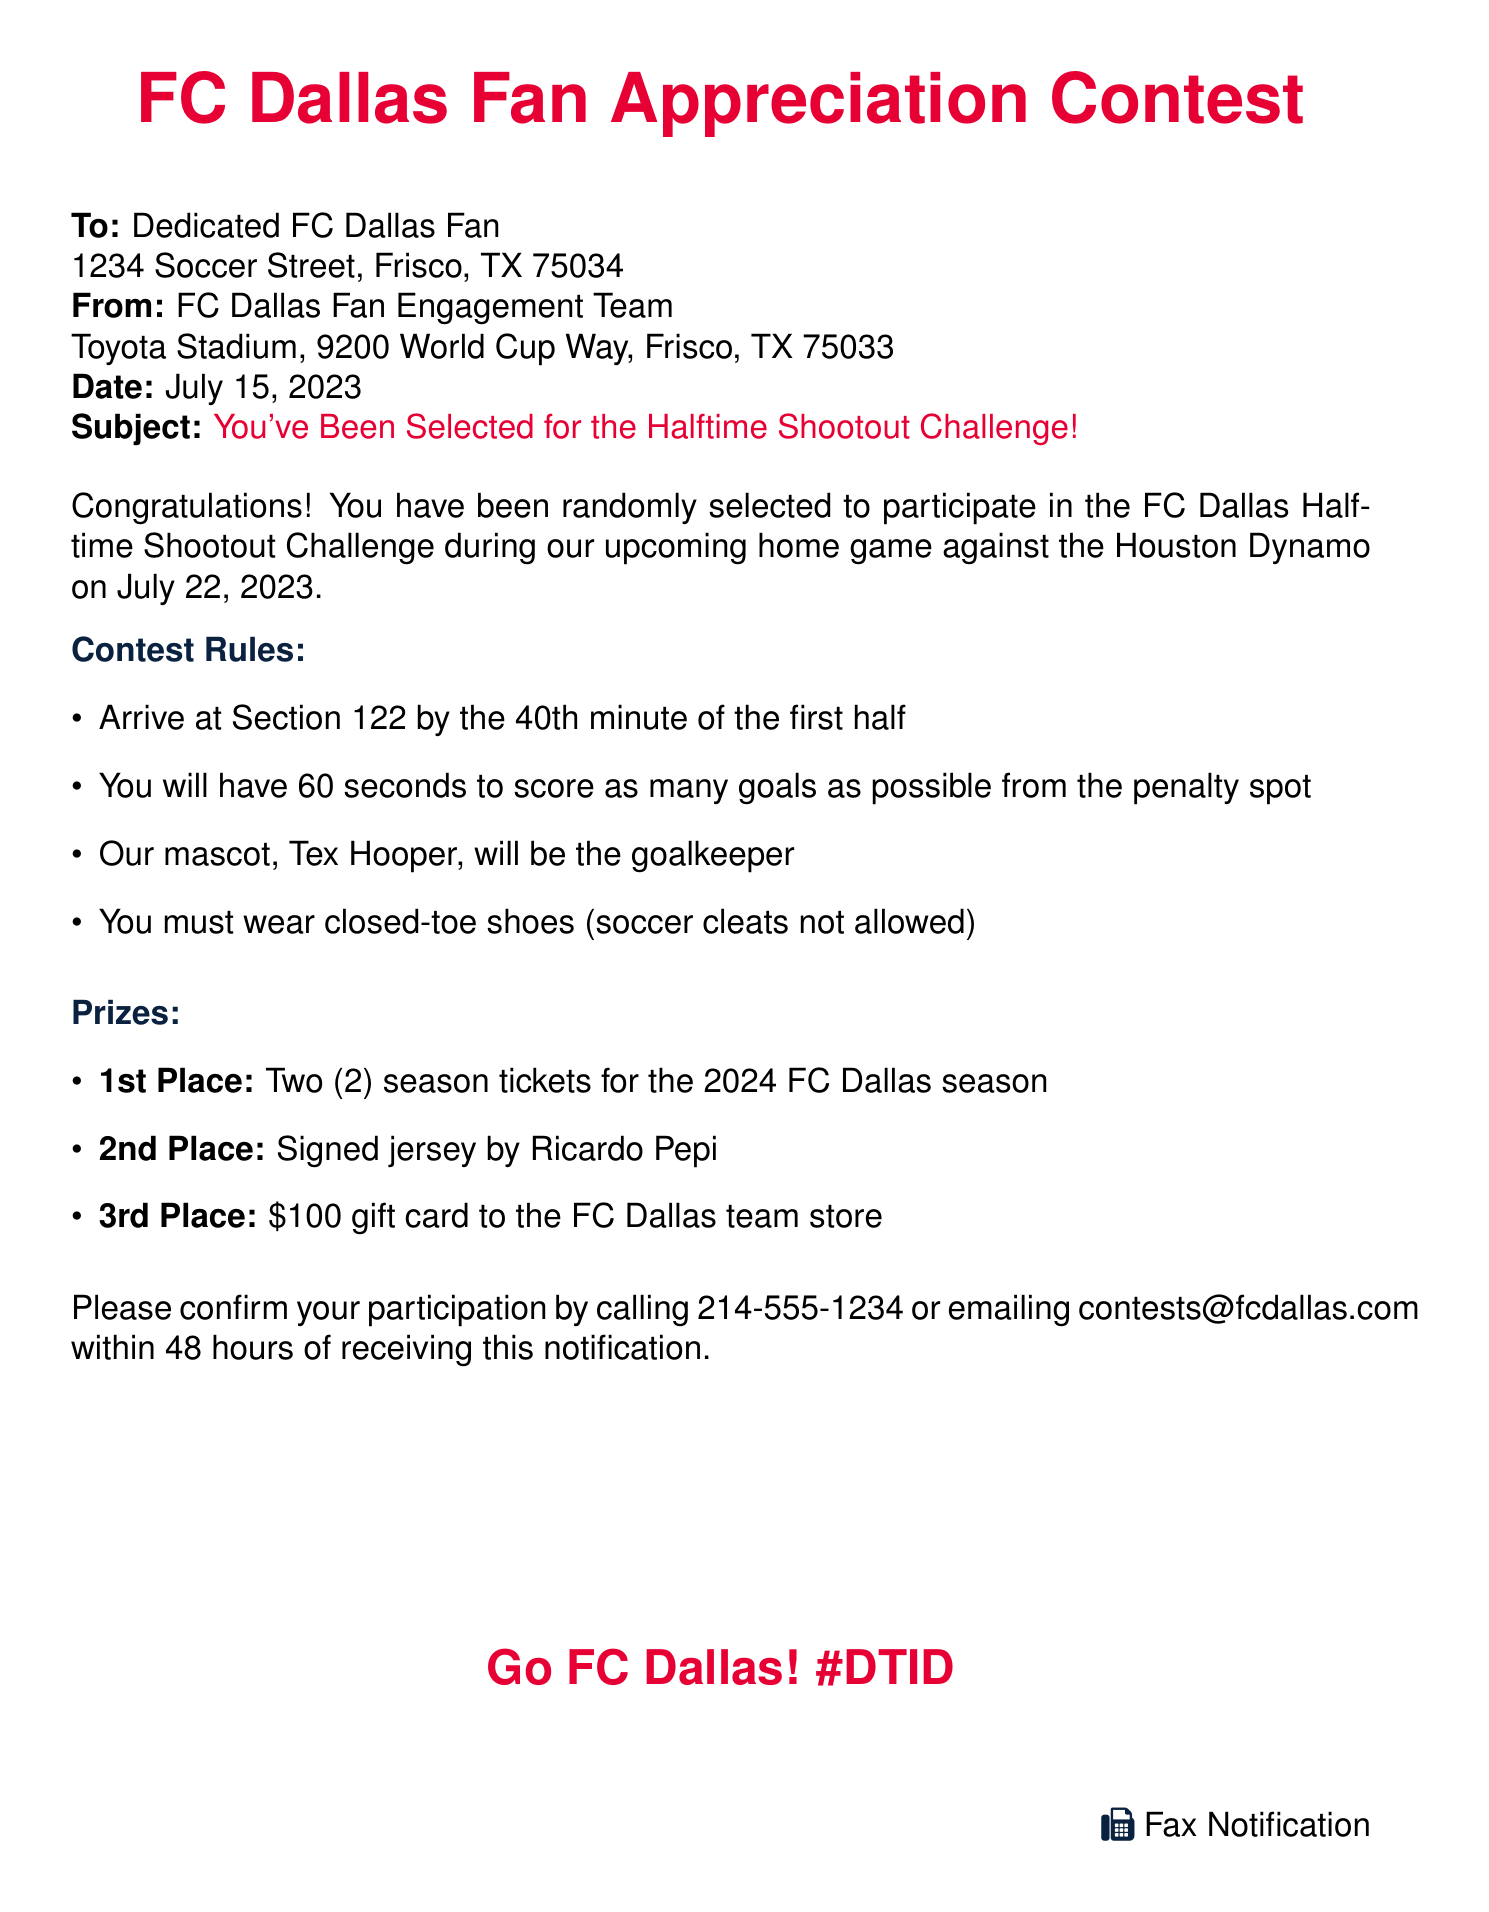What is the title of the contest? The title of the contest is mentioned at the beginning of the document.
Answer: FC Dallas Fan Appreciation Contest What is the date of the home game? The date of the home game is specified in the notification.
Answer: July 22, 2023 Where should participants arrive? The location participants need to arrive at is mentioned in the rules section.
Answer: Section 122 What is the maximum time allowed for scoring goals? The time limit for the scoring challenge is indicated in the contest rules.
Answer: 60 seconds What is the prize for 1st place? The prize for 1st place is clearly listed in the prizes section.
Answer: Two (2) season tickets for the 2024 FC Dallas season Who is the goalkeeper for the shootout? The document specifies who will be the goalkeeper during the challenge.
Answer: Tex Hooper What footwear is required for participants? The footwear requirement is stated in the contest rules.
Answer: Closed-toe shoes How to confirm participation? The document provides methods for confirming participation.
Answer: Call 214-555-1234 or email contests@fcdallas.com What is the faxing team's name? The name of the team sending the fax is included in the contact information.
Answer: FC Dallas Fan Engagement Team 